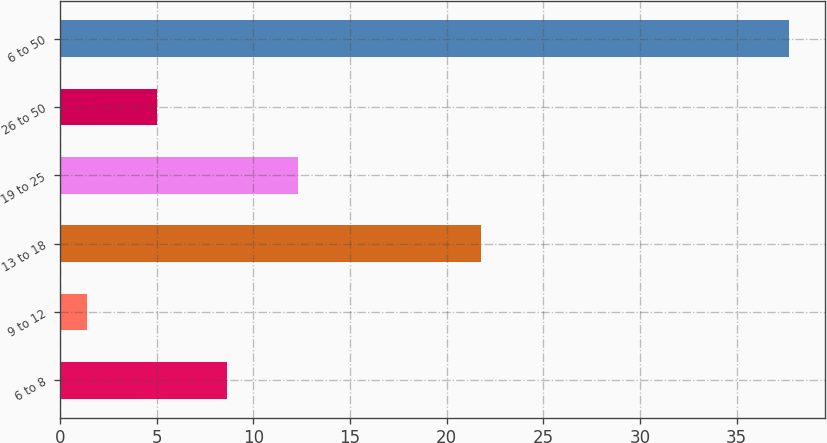Convert chart to OTSL. <chart><loc_0><loc_0><loc_500><loc_500><bar_chart><fcel>6 to 8<fcel>9 to 12<fcel>13 to 18<fcel>19 to 25<fcel>26 to 50<fcel>6 to 50<nl><fcel>8.66<fcel>1.4<fcel>21.8<fcel>12.29<fcel>5.03<fcel>37.7<nl></chart> 